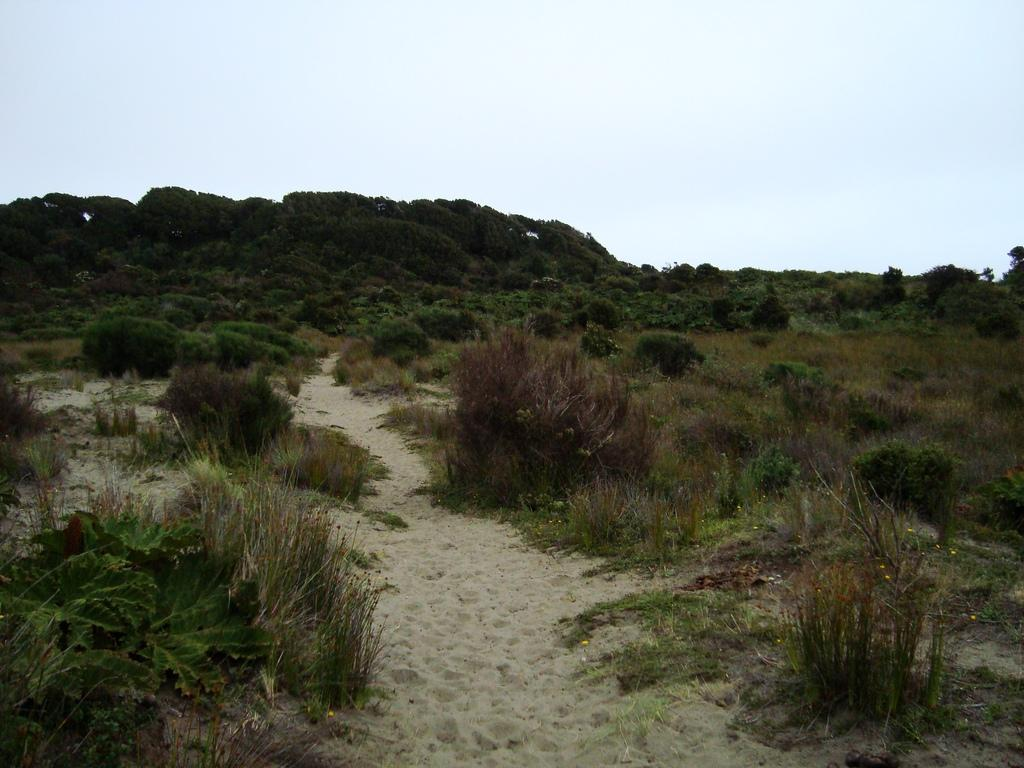What can be seen in the foreground of the image? There is a sand path in the foreground of the image. What type of vegetation is present alongside the sand path? Plants and grass are present on either side of the sand path. What is visible in the background of the image? There are trees and the sky in the background of the image. What type of stew is being cooked in the image? There is no stew present in the image; it features a sand path, plants, grass, trees, and the sky. 